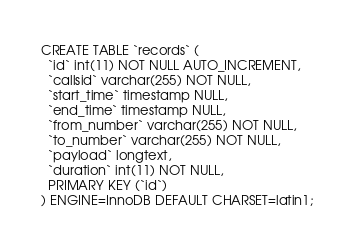<code> <loc_0><loc_0><loc_500><loc_500><_SQL_>CREATE TABLE `records` (
  `id` int(11) NOT NULL AUTO_INCREMENT,
  `callsid` varchar(255) NOT NULL,
  `start_time` timestamp NULL,
  `end_time` timestamp NULL,
  `from_number` varchar(255) NOT NULL,
  `to_number` varchar(255) NOT NULL,
  `payload` longtext,
  `duration` int(11) NOT NULL,
  PRIMARY KEY (`id`)
) ENGINE=InnoDB DEFAULT CHARSET=latin1;
</code> 